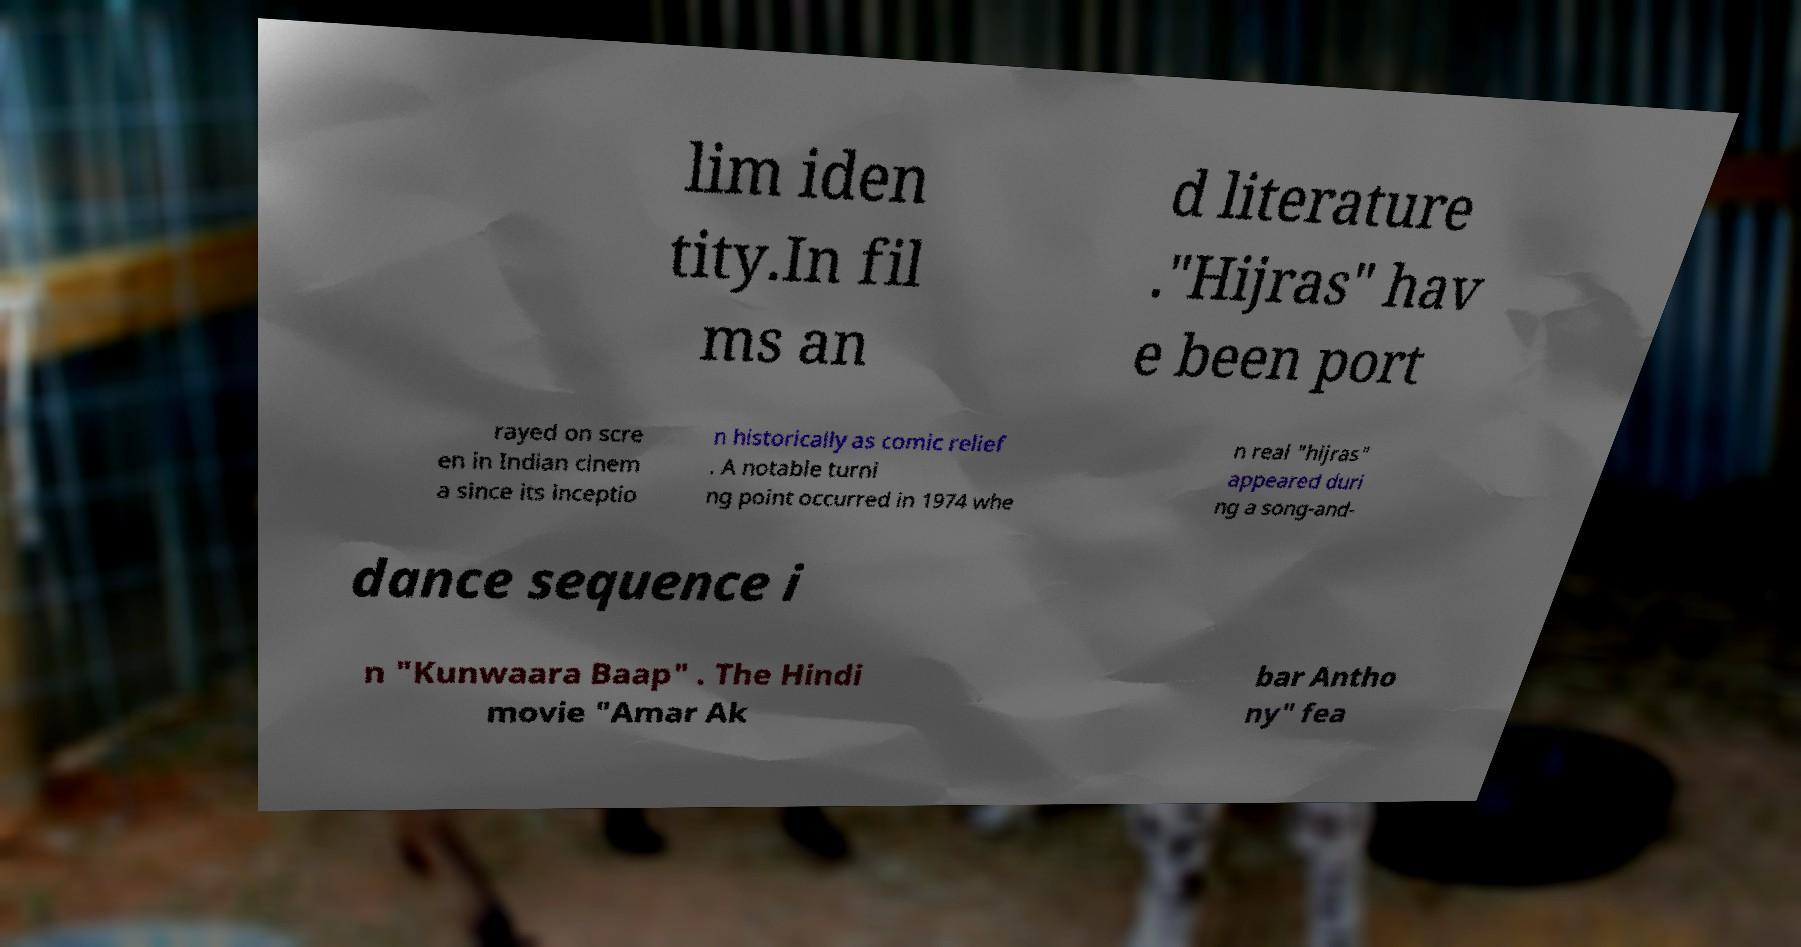Can you read and provide the text displayed in the image?This photo seems to have some interesting text. Can you extract and type it out for me? lim iden tity.In fil ms an d literature ."Hijras" hav e been port rayed on scre en in Indian cinem a since its inceptio n historically as comic relief . A notable turni ng point occurred in 1974 whe n real "hijras" appeared duri ng a song-and- dance sequence i n "Kunwaara Baap" . The Hindi movie "Amar Ak bar Antho ny" fea 